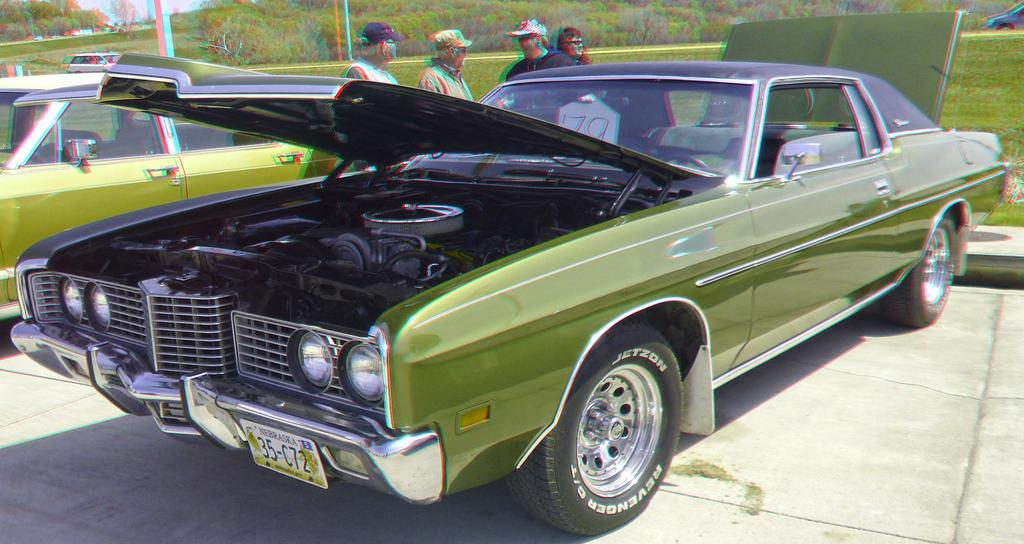What can be said about the nature of the image? The image is edited. What types of objects are on the floor in the image? There are motor vehicles and persons standing on the floor. What structures are present in the image? There are poles in the image. What type of natural environment is visible in the image? There is grass, trees, and the sky visible in the image. Can you tell me how many umbrellas are being used by the persons in the image? There is no mention of umbrellas in the image; the focus is on motor vehicles, persons, poles, grass, trees, and the sky. What type of brick is being used to construct the poles in the image? There is no mention of bricks or the construction of the poles in the image; the focus is on their presence and not their composition. 